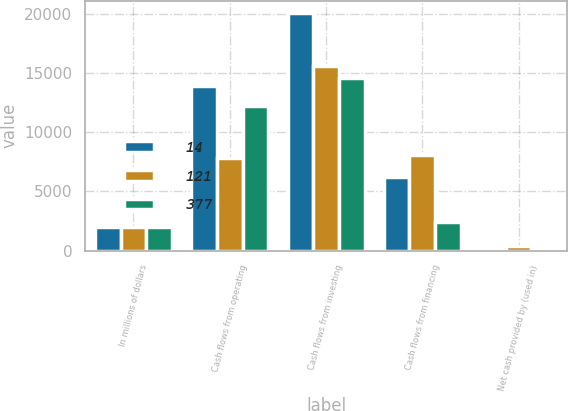Convert chart to OTSL. <chart><loc_0><loc_0><loc_500><loc_500><stacked_bar_chart><ecel><fcel>In millions of dollars<fcel>Cash flows from operating<fcel>Cash flows from investing<fcel>Cash flows from financing<fcel>Net cash provided by (used in)<nl><fcel>14<fcel>2009<fcel>13872<fcel>20085<fcel>6227<fcel>14<nl><fcel>121<fcel>2008<fcel>7859<fcel>15590<fcel>8108<fcel>377<nl><fcel>377<fcel>2007<fcel>12248<fcel>14581<fcel>2454<fcel>121<nl></chart> 